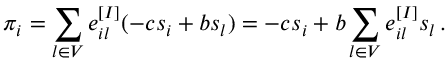Convert formula to latex. <formula><loc_0><loc_0><loc_500><loc_500>\pi _ { i } = \sum _ { l \in V } e _ { i l } ^ { [ I ] } ( - c s _ { i } + b s _ { l } ) = - c s _ { i } + b \sum _ { l \in V } e _ { i l } ^ { [ I ] } s _ { l } \, .</formula> 